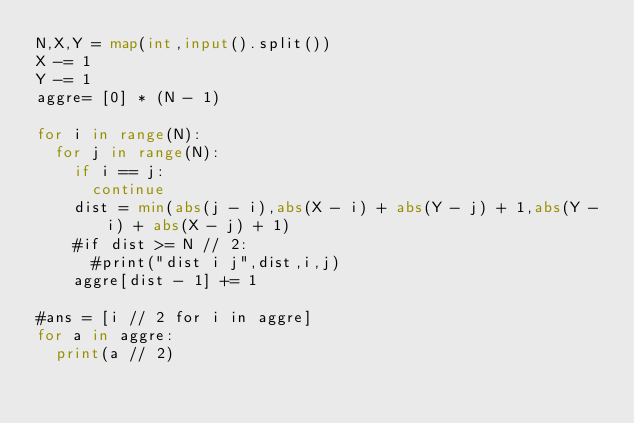Convert code to text. <code><loc_0><loc_0><loc_500><loc_500><_Python_>N,X,Y = map(int,input().split())
X -= 1
Y -= 1
aggre= [0] * (N - 1)

for i in range(N):
  for j in range(N):
    if i == j:
      continue
    dist = min(abs(j - i),abs(X - i) + abs(Y - j) + 1,abs(Y - i) + abs(X - j) + 1)
    #if dist >= N // 2:
      #print("dist i j",dist,i,j)
    aggre[dist - 1] += 1
    
#ans = [i // 2 for i in aggre]
for a in aggre:
  print(a // 2)</code> 